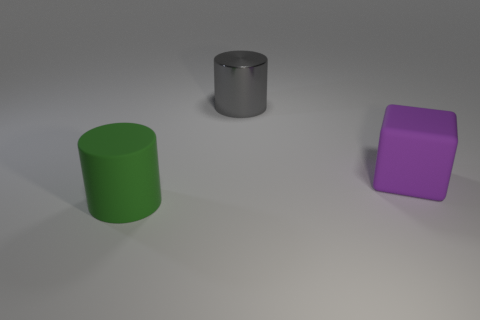Does the thing in front of the purple rubber cube have the same material as the object that is behind the large rubber cube?
Your response must be concise. No. Is the number of things on the right side of the big metallic cylinder greater than the number of large yellow matte blocks?
Keep it short and to the point. Yes. There is a big cylinder that is to the left of the object behind the rubber block; what is its color?
Provide a succinct answer. Green. What is the shape of the green rubber object that is the same size as the metallic cylinder?
Your answer should be very brief. Cylinder. Is the number of large purple cubes that are to the left of the gray cylinder the same as the number of purple objects?
Your answer should be compact. No. There is a cylinder that is behind the thing on the left side of the cylinder behind the block; what is its material?
Your response must be concise. Metal. The big purple thing that is the same material as the green cylinder is what shape?
Offer a very short reply. Cube. Is there anything else that is the same color as the rubber block?
Make the answer very short. No. How many blocks are behind the big rubber thing that is to the right of the gray shiny cylinder that is behind the purple block?
Your answer should be very brief. 0. What number of yellow objects are either large cylinders or metal things?
Provide a succinct answer. 0. 